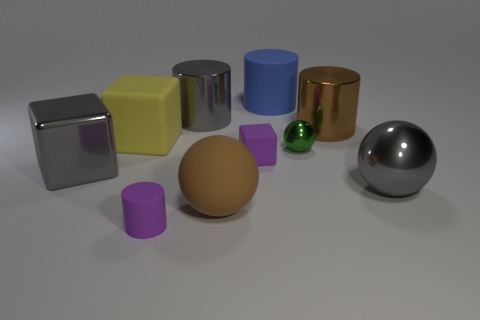There is a thing that is the same color as the big rubber sphere; what is its shape?
Your answer should be very brief. Cylinder. Is there a cyan thing made of the same material as the large gray cylinder?
Keep it short and to the point. No. The green shiny thing is what size?
Make the answer very short. Small. How many gray objects are large rubber blocks or large metal blocks?
Your answer should be very brief. 1. What number of other big objects have the same shape as the big blue rubber thing?
Provide a succinct answer. 2. What number of yellow rubber objects have the same size as the gray metal sphere?
Ensure brevity in your answer.  1. What material is the tiny purple object that is the same shape as the big yellow thing?
Give a very brief answer. Rubber. There is a metal thing on the right side of the large brown metallic cylinder; what is its color?
Offer a very short reply. Gray. Are there more blue matte things that are behind the blue matte thing than blue rubber cylinders?
Your answer should be very brief. No. What is the color of the large rubber ball?
Make the answer very short. Brown. 